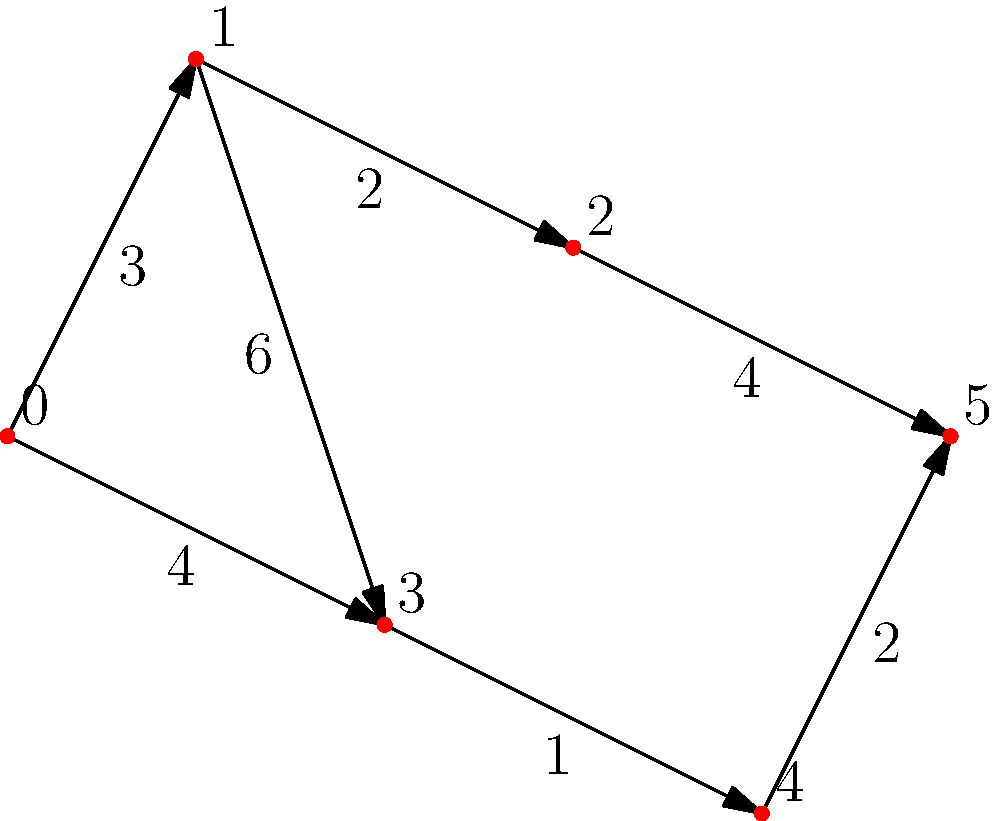Given the network of wrestling mats represented by the graph, where each node is a mat station and the edges represent paths between stations with their respective times (in minutes) to traverse, what is the shortest time required to complete a warmup routine starting at mat 0 and ending at mat 5? To find the shortest path from mat 0 to mat 5, we'll use Dijkstra's algorithm:

1. Initialize distances: $d[0]=0$, all others $\infty$
2. Start from node 0:
   - Update $d[1] = 3$ and $d[3] = 4$
3. Select node 1 (smallest unvisited):
   - Update $d[2] = 3+2 = 5$
   - $d[3]$ remains 4
4. Select node 3:
   - Update $d[4] = 4+1 = 5$
5. Select node 2:
   - Update $d[5] = 5+4 = 9$
6. Select node 4:
   - Update $d[5] = 5+2 = 7$

The shortest path is 0 -> 3 -> 4 -> 5, with a total time of 7 minutes.
Answer: 7 minutes 